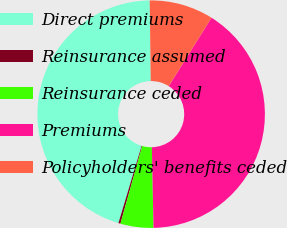Convert chart to OTSL. <chart><loc_0><loc_0><loc_500><loc_500><pie_chart><fcel>Direct premiums<fcel>Reinsurance assumed<fcel>Reinsurance ceded<fcel>Premiums<fcel>Policyholders' benefits ceded<nl><fcel>45.16%<fcel>0.29%<fcel>4.69%<fcel>40.76%<fcel>9.1%<nl></chart> 